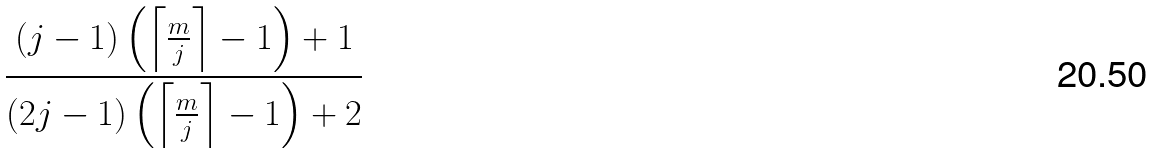Convert formula to latex. <formula><loc_0><loc_0><loc_500><loc_500>\frac { ( j - 1 ) \left ( \left \lceil \frac { m } { j } \right \rceil - 1 \right ) + 1 } { ( 2 j - 1 ) \left ( \left \lceil \frac { m } { j } \right \rceil - 1 \right ) + 2 }</formula> 